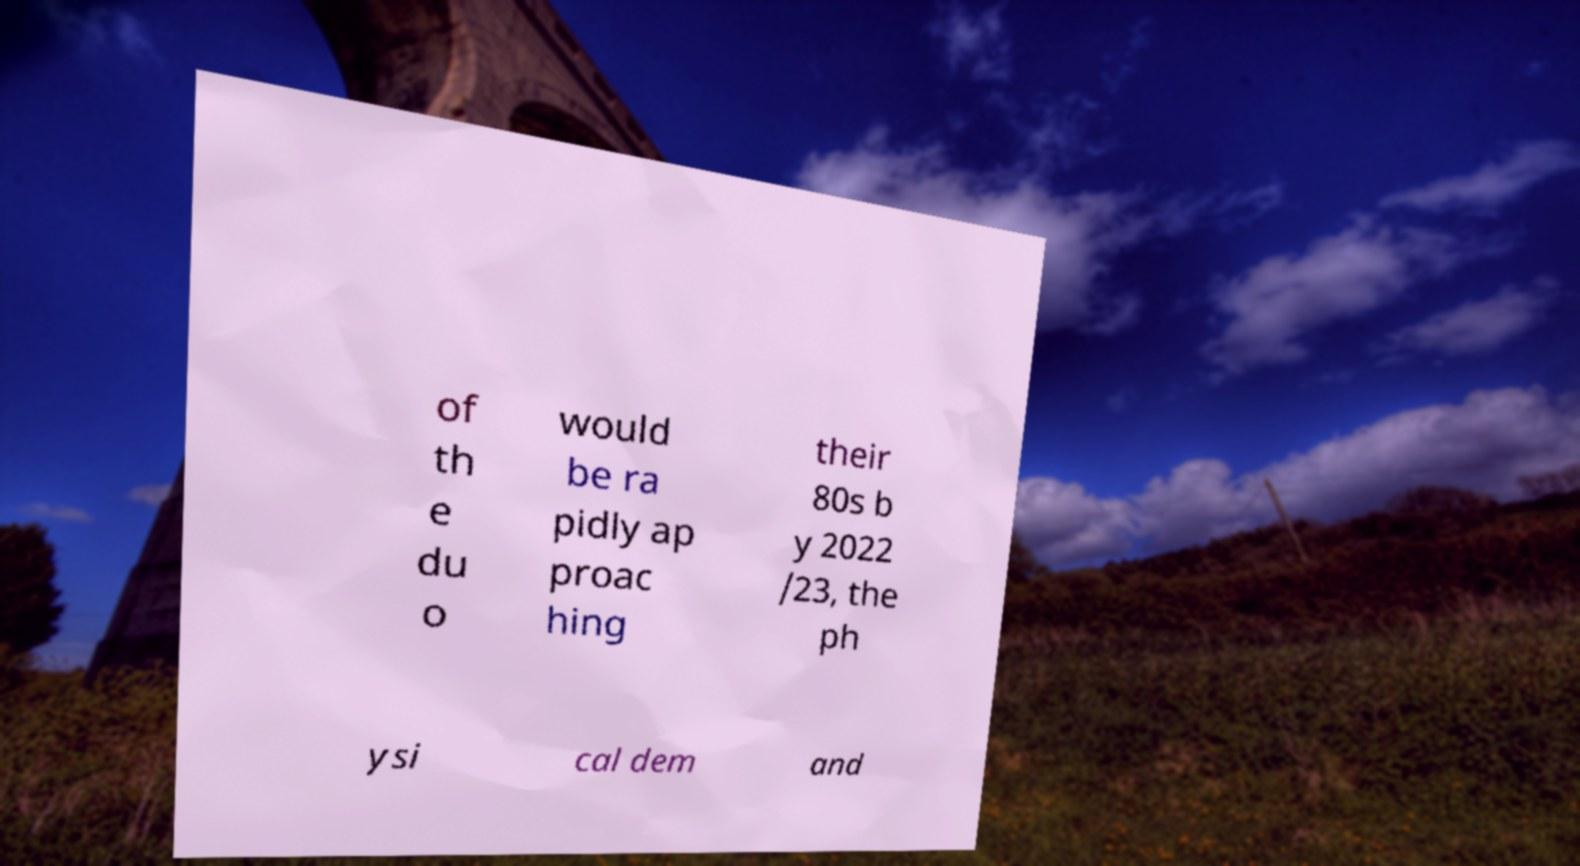Could you assist in decoding the text presented in this image and type it out clearly? of th e du o would be ra pidly ap proac hing their 80s b y 2022 /23, the ph ysi cal dem and 